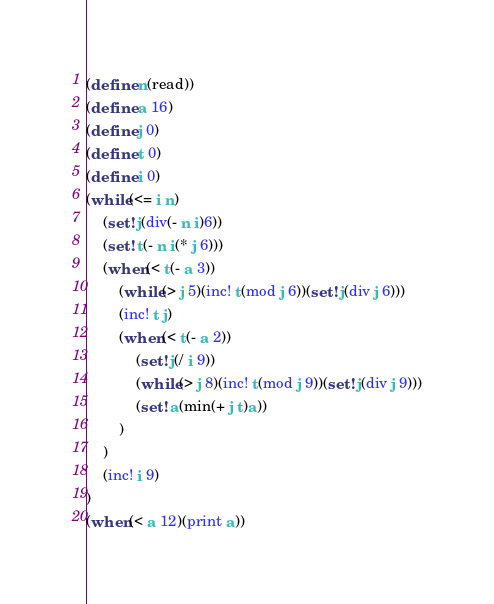<code> <loc_0><loc_0><loc_500><loc_500><_Scheme_>(define n(read))
(define a 16)
(define j 0)
(define t 0)
(define i 0)
(while(<= i n)
	(set! j(div(- n i)6))
	(set! t(- n i(* j 6)))
	(when(< t(- a 3))
		(while(> j 5)(inc! t(mod j 6))(set! j(div j 6)))
		(inc! t j)
		(when(< t(- a 2))
			(set! j(/ i 9))
			(while(> j 8)(inc! t(mod j 9))(set! j(div j 9)))
			(set! a(min(+ j t)a))
		)
	)
	(inc! i 9)
)
(when(< a 12)(print a))</code> 